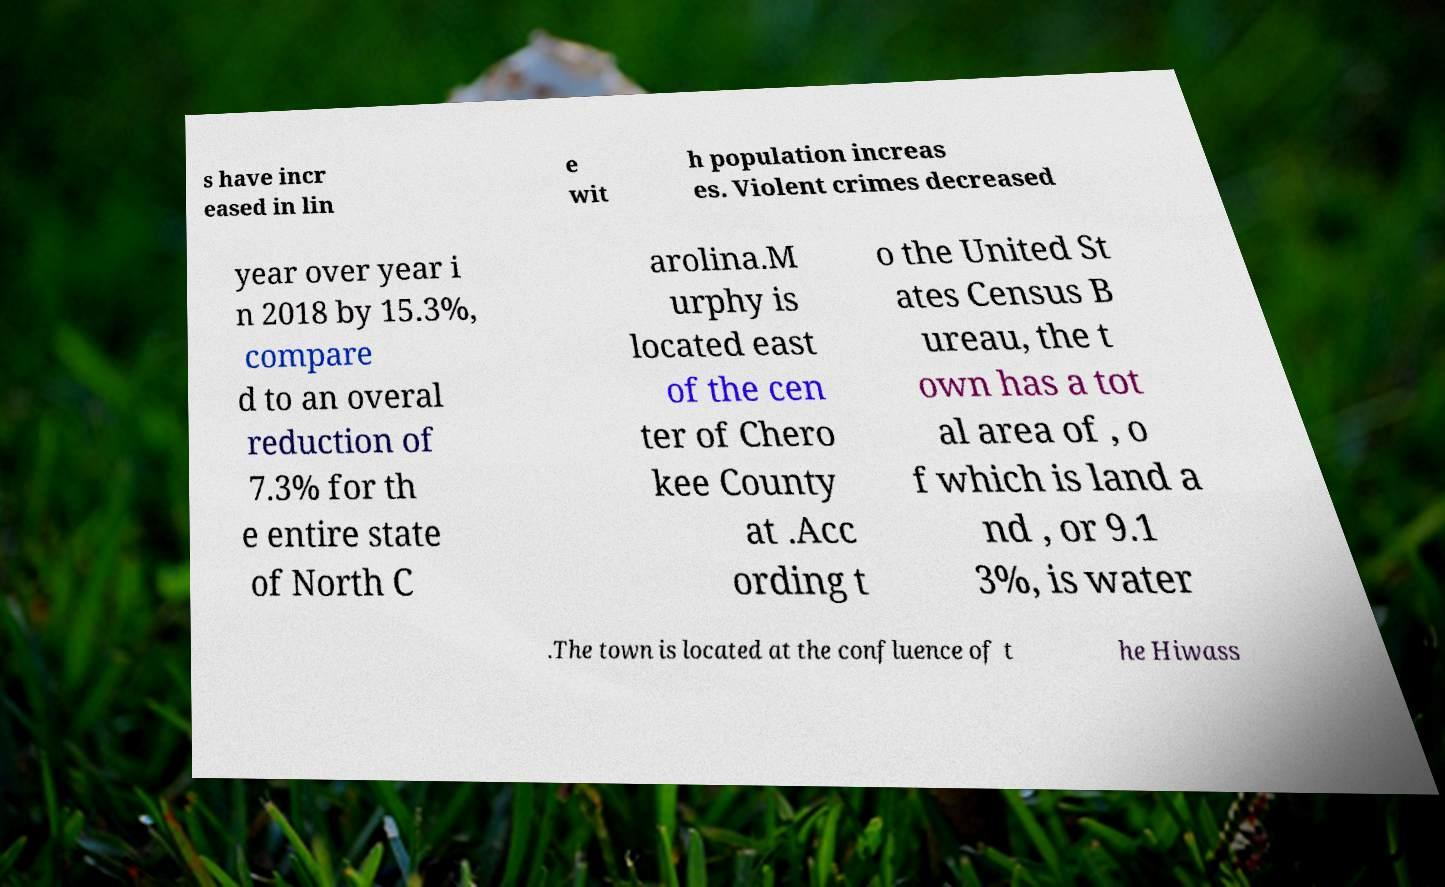For documentation purposes, I need the text within this image transcribed. Could you provide that? s have incr eased in lin e wit h population increas es. Violent crimes decreased year over year i n 2018 by 15.3%, compare d to an overal reduction of 7.3% for th e entire state of North C arolina.M urphy is located east of the cen ter of Chero kee County at .Acc ording t o the United St ates Census B ureau, the t own has a tot al area of , o f which is land a nd , or 9.1 3%, is water .The town is located at the confluence of t he Hiwass 